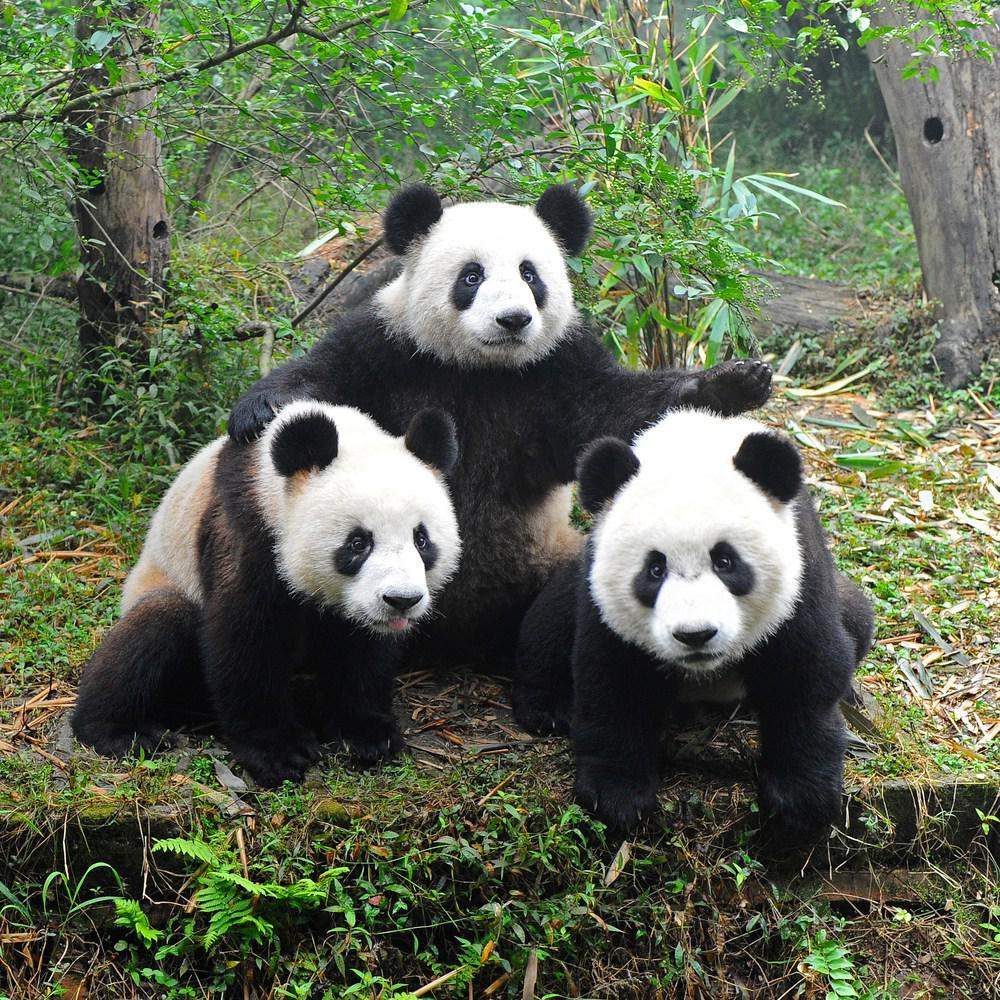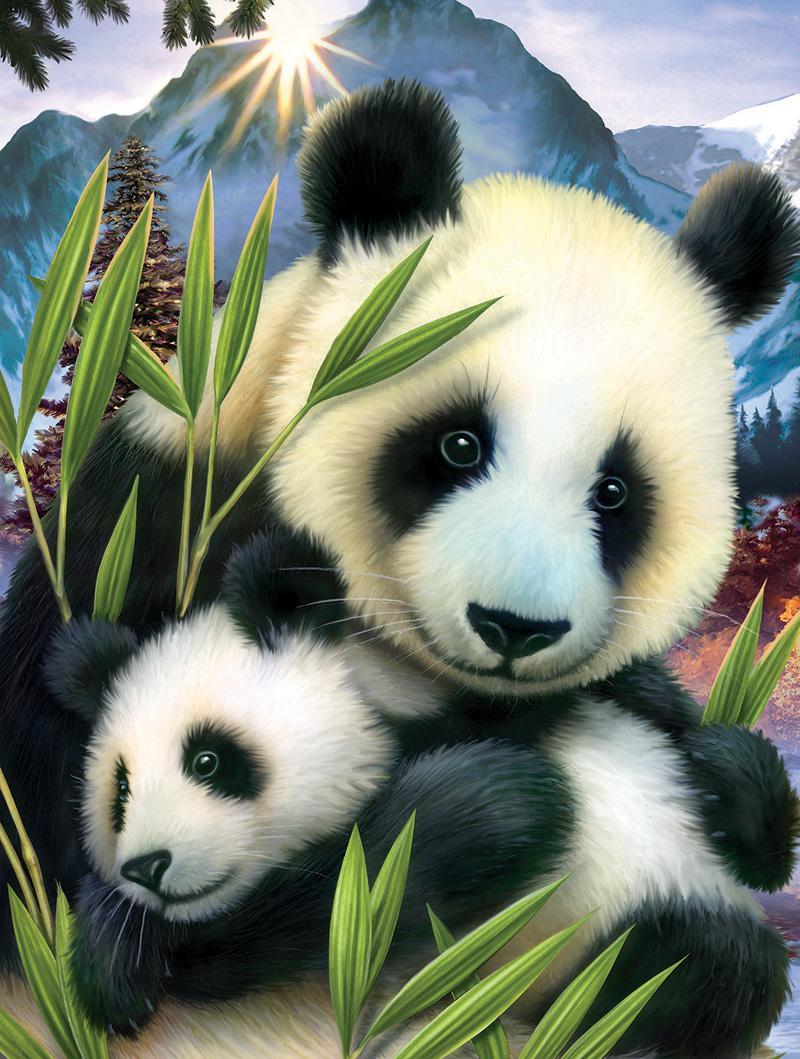The first image is the image on the left, the second image is the image on the right. Considering the images on both sides, is "Three pandas are grouped together on the ground in the image on the left." valid? Answer yes or no. Yes. 